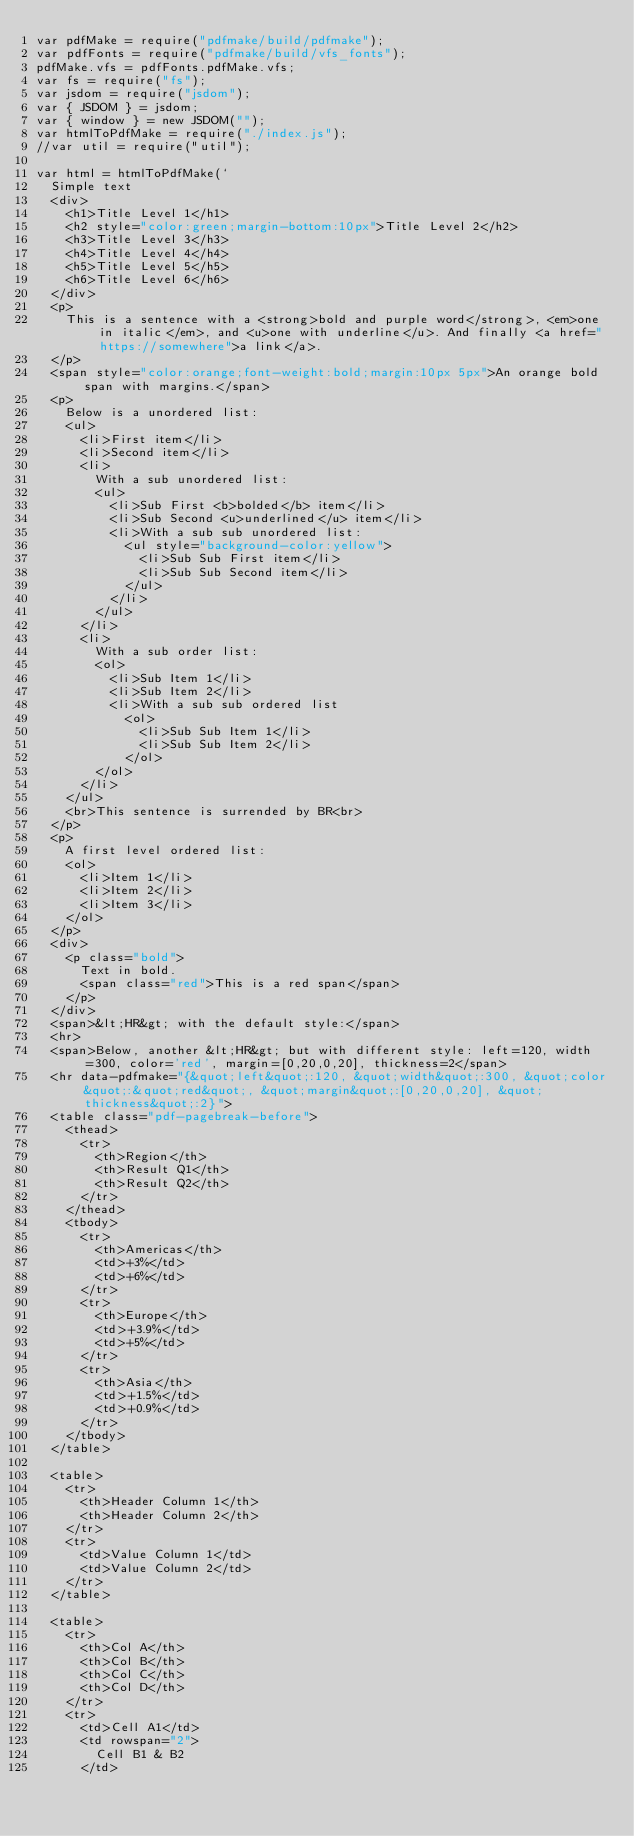Convert code to text. <code><loc_0><loc_0><loc_500><loc_500><_JavaScript_>var pdfMake = require("pdfmake/build/pdfmake");
var pdfFonts = require("pdfmake/build/vfs_fonts");
pdfMake.vfs = pdfFonts.pdfMake.vfs;
var fs = require("fs");
var jsdom = require("jsdom");
var { JSDOM } = jsdom;
var { window } = new JSDOM("");
var htmlToPdfMake = require("./index.js");
//var util = require("util");

var html = htmlToPdfMake(`
  Simple text
  <div>
    <h1>Title Level 1</h1>
    <h2 style="color:green;margin-bottom:10px">Title Level 2</h2>
    <h3>Title Level 3</h3>
    <h4>Title Level 4</h4>
    <h5>Title Level 5</h5>
    <h6>Title Level 6</h6>
  </div>
  <p>
    This is a sentence with a <strong>bold and purple word</strong>, <em>one in italic</em>, and <u>one with underline</u>. And finally <a href="https://somewhere">a link</a>.
  </p>
  <span style="color:orange;font-weight:bold;margin:10px 5px">An orange bold span with margins.</span>
  <p>
    Below is a unordered list:
    <ul>
      <li>First item</li>
      <li>Second item</li>
      <li>
        With a sub unordered list:
        <ul>
          <li>Sub First <b>bolded</b> item</li>
          <li>Sub Second <u>underlined</u> item</li>
          <li>With a sub sub unordered list:
            <ul style="background-color:yellow">
              <li>Sub Sub First item</li>
              <li>Sub Sub Second item</li>
            </ul>
          </li>
        </ul>
      </li>
      <li>
        With a sub order list:
        <ol>
          <li>Sub Item 1</li>
          <li>Sub Item 2</li>
          <li>With a sub sub ordered list
            <ol>
              <li>Sub Sub Item 1</li>
              <li>Sub Sub Item 2</li>
            </ol>
        </ol>
      </li>
    </ul>
    <br>This sentence is surrended by BR<br>
  </p>
  <p>
    A first level ordered list:
    <ol>
      <li>Item 1</li>
      <li>Item 2</li>
      <li>Item 3</li>
    </ol>
  </p>
  <div>
    <p class="bold">
      Text in bold.
      <span class="red">This is a red span</span>
    </p>
  </div>
  <span>&lt;HR&gt; with the default style:</span>
  <hr>
  <span>Below, another &lt;HR&gt; but with different style: left=120, width=300, color='red', margin=[0,20,0,20], thickness=2</span>
  <hr data-pdfmake="{&quot;left&quot;:120, &quot;width&quot;:300, &quot;color&quot;:&quot;red&quot;, &quot;margin&quot;:[0,20,0,20], &quot;thickness&quot;:2}">
  <table class="pdf-pagebreak-before">
    <thead>
      <tr>
        <th>Region</th>
        <th>Result Q1</th>
        <th>Result Q2</th>
      </tr>
    </thead>
    <tbody>
      <tr>
        <th>Americas</th>
        <td>+3%</td>
        <td>+6%</td>
      </tr>
      <tr>
        <th>Europe</th>
        <td>+3.9%</td>
        <td>+5%</td>
      </tr>
      <tr>
        <th>Asia</th>
        <td>+1.5%</td>
        <td>+0.9%</td>
      </tr>
    </tbody>
  </table>

  <table>
    <tr>
      <th>Header Column 1</th>
      <th>Header Column 2</th>
    </tr>
    <tr>
      <td>Value Column 1</td>
      <td>Value Column 2</td>
    </tr>
  </table>

  <table>
    <tr>
      <th>Col A</th>
      <th>Col B</th>
      <th>Col C</th>
      <th>Col D</th>
    </tr>
    <tr>
      <td>Cell A1</td>
      <td rowspan="2">
        Cell B1 & B2
      </td></code> 